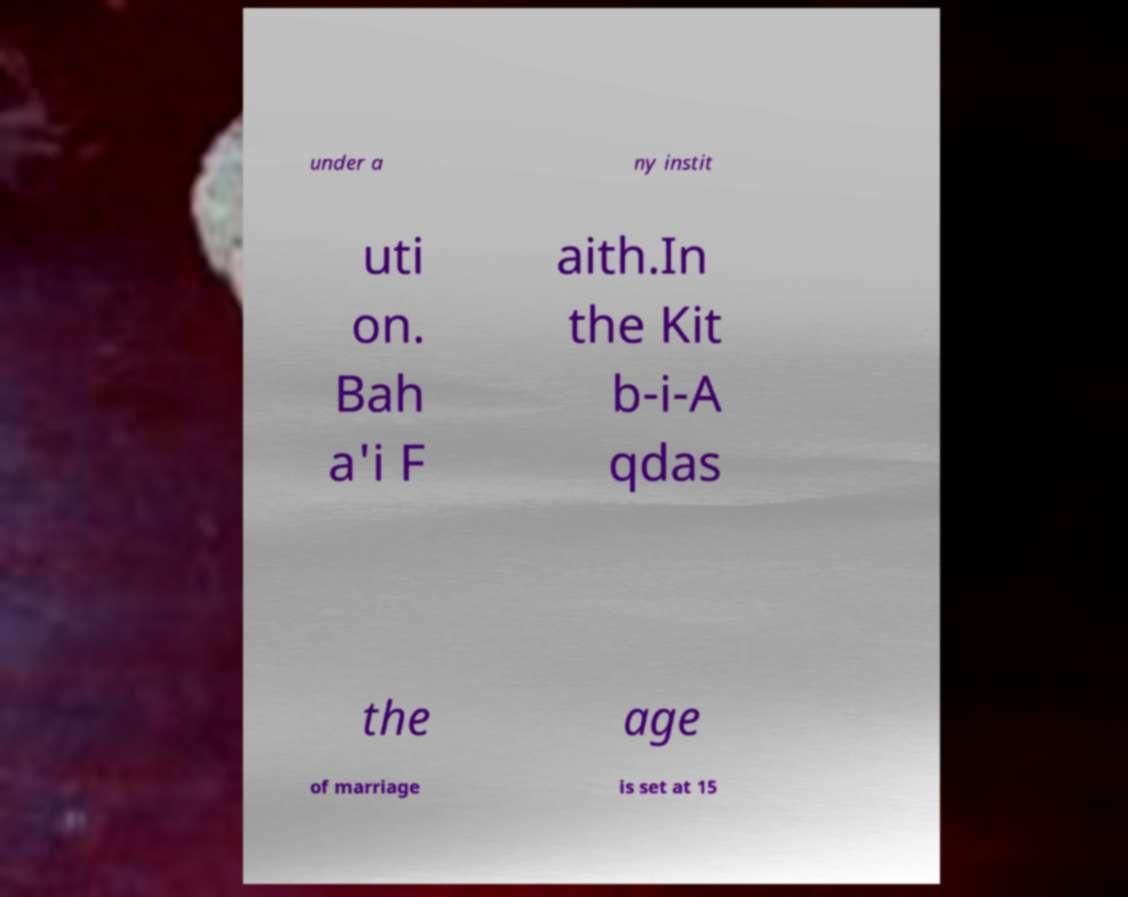For documentation purposes, I need the text within this image transcribed. Could you provide that? under a ny instit uti on. Bah a'i F aith.In the Kit b-i-A qdas the age of marriage is set at 15 